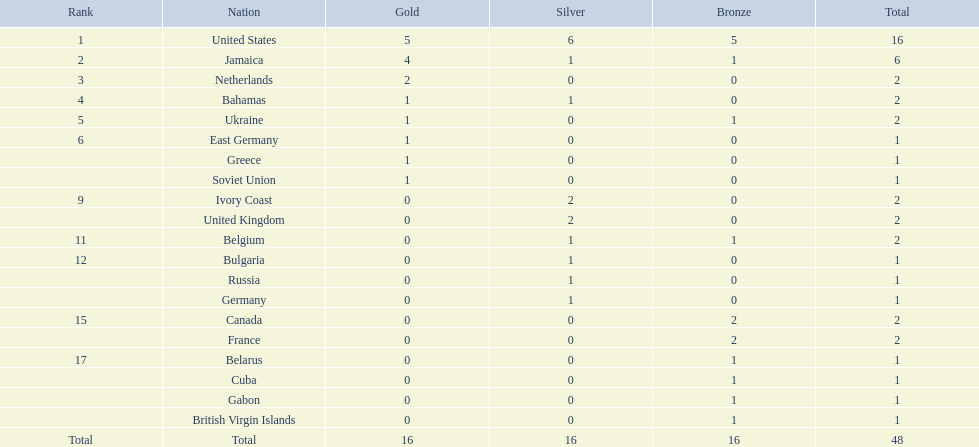What country won the most medals? United States. How many medals did the us win? 16. What is the most medals (after 16) that were won by a country? 6. Which country won 6 medals? Jamaica. 